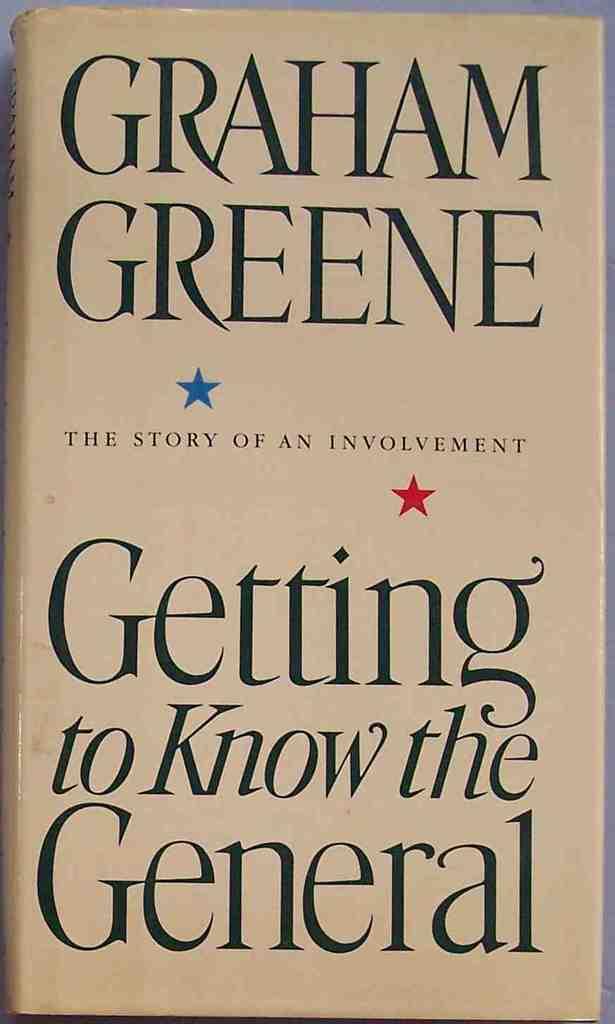Who is the author?
Ensure brevity in your answer.  Graham greene. 